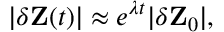Convert formula to latex. <formula><loc_0><loc_0><loc_500><loc_500>| \delta Z ( t ) | \approx e ^ { \lambda t } | \delta Z _ { 0 } | ,</formula> 